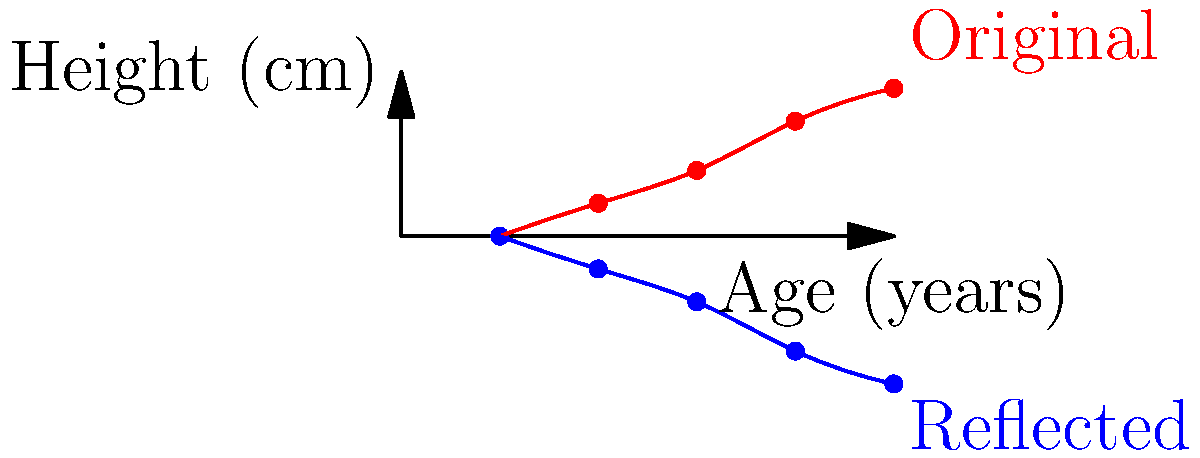A mother has been tracking her child's growth on a chart. She decides to reflect the growth curve across the horizontal line representing the starting height to visualize progress. If the child's height at age 5 was 145 cm and the starting height was 100 cm, what would be the y-coordinate of the reflected point for age 5? To solve this problem, we need to follow these steps:

1) First, we need to understand what reflection across a horizontal line means. When we reflect a point across a horizontal line, the distance of the point from the line remains the same, but on the opposite side.

2) The horizontal line of reflection is at the starting height, which is 100 cm.

3) The original point at age 5 is at 145 cm.

4) To find the distance of this point from the line of reflection:
   $145 \text{ cm} - 100 \text{ cm} = 45 \text{ cm}$

5) For the reflected point, this distance will be the same, but below the line of reflection.

6) So, we calculate the y-coordinate of the reflected point:
   $100 \text{ cm} - 45 \text{ cm} = 55 \text{ cm}$

Therefore, the y-coordinate of the reflected point for age 5 would be 55 cm.
Answer: 55 cm 